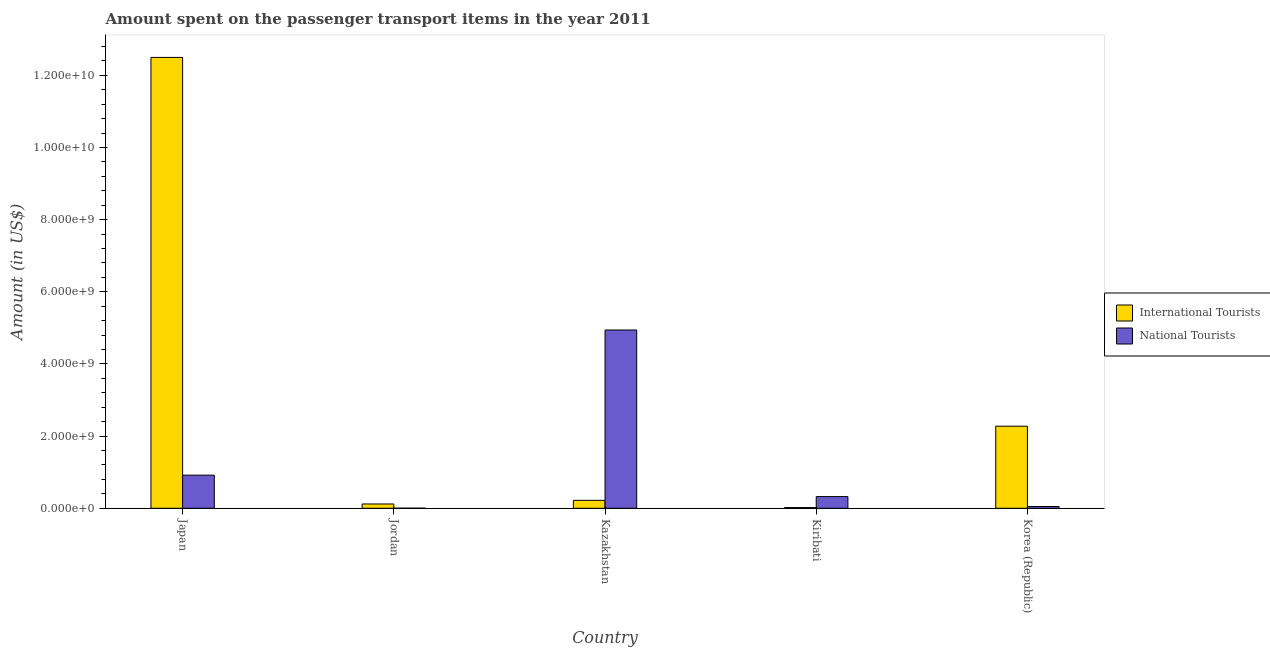How many groups of bars are there?
Ensure brevity in your answer.  5. Are the number of bars per tick equal to the number of legend labels?
Offer a terse response. Yes. What is the label of the 5th group of bars from the left?
Your answer should be very brief. Korea (Republic). In how many cases, is the number of bars for a given country not equal to the number of legend labels?
Make the answer very short. 0. What is the amount spent on transport items of national tourists in Kazakhstan?
Your answer should be compact. 4.94e+09. Across all countries, what is the maximum amount spent on transport items of international tourists?
Your answer should be compact. 1.25e+1. In which country was the amount spent on transport items of international tourists maximum?
Ensure brevity in your answer.  Japan. In which country was the amount spent on transport items of national tourists minimum?
Offer a very short reply. Jordan. What is the total amount spent on transport items of national tourists in the graph?
Ensure brevity in your answer.  6.24e+09. What is the difference between the amount spent on transport items of international tourists in Japan and that in Kiribati?
Your answer should be very brief. 1.25e+1. What is the difference between the amount spent on transport items of national tourists in Japan and the amount spent on transport items of international tourists in Korea (Republic)?
Provide a succinct answer. -1.36e+09. What is the average amount spent on transport items of international tourists per country?
Offer a terse response. 3.03e+09. What is the difference between the amount spent on transport items of international tourists and amount spent on transport items of national tourists in Korea (Republic)?
Keep it short and to the point. 2.23e+09. What is the ratio of the amount spent on transport items of international tourists in Kazakhstan to that in Korea (Republic)?
Your answer should be compact. 0.1. Is the difference between the amount spent on transport items of international tourists in Japan and Jordan greater than the difference between the amount spent on transport items of national tourists in Japan and Jordan?
Your answer should be compact. Yes. What is the difference between the highest and the second highest amount spent on transport items of national tourists?
Provide a short and direct response. 4.02e+09. What is the difference between the highest and the lowest amount spent on transport items of international tourists?
Ensure brevity in your answer.  1.25e+1. In how many countries, is the amount spent on transport items of international tourists greater than the average amount spent on transport items of international tourists taken over all countries?
Offer a terse response. 1. What does the 1st bar from the left in Jordan represents?
Your answer should be compact. International Tourists. What does the 2nd bar from the right in Jordan represents?
Offer a very short reply. International Tourists. What is the difference between two consecutive major ticks on the Y-axis?
Offer a very short reply. 2.00e+09. Are the values on the major ticks of Y-axis written in scientific E-notation?
Provide a short and direct response. Yes. Does the graph contain any zero values?
Ensure brevity in your answer.  No. Does the graph contain grids?
Your response must be concise. No. Where does the legend appear in the graph?
Offer a very short reply. Center right. How many legend labels are there?
Ensure brevity in your answer.  2. What is the title of the graph?
Provide a succinct answer. Amount spent on the passenger transport items in the year 2011. What is the Amount (in US$) in International Tourists in Japan?
Provide a succinct answer. 1.25e+1. What is the Amount (in US$) in National Tourists in Japan?
Offer a terse response. 9.18e+08. What is the Amount (in US$) of International Tourists in Jordan?
Make the answer very short. 1.19e+08. What is the Amount (in US$) in National Tourists in Jordan?
Make the answer very short. 2.00e+06. What is the Amount (in US$) of International Tourists in Kazakhstan?
Ensure brevity in your answer.  2.20e+08. What is the Amount (in US$) of National Tourists in Kazakhstan?
Provide a succinct answer. 4.94e+09. What is the Amount (in US$) of International Tourists in Kiribati?
Provide a short and direct response. 1.95e+07. What is the Amount (in US$) in National Tourists in Kiribati?
Offer a terse response. 3.24e+08. What is the Amount (in US$) of International Tourists in Korea (Republic)?
Make the answer very short. 2.28e+09. What is the Amount (in US$) of National Tourists in Korea (Republic)?
Provide a succinct answer. 4.90e+07. Across all countries, what is the maximum Amount (in US$) of International Tourists?
Provide a succinct answer. 1.25e+1. Across all countries, what is the maximum Amount (in US$) in National Tourists?
Your answer should be compact. 4.94e+09. Across all countries, what is the minimum Amount (in US$) in International Tourists?
Keep it short and to the point. 1.95e+07. What is the total Amount (in US$) in International Tourists in the graph?
Provide a short and direct response. 1.51e+1. What is the total Amount (in US$) in National Tourists in the graph?
Provide a succinct answer. 6.24e+09. What is the difference between the Amount (in US$) in International Tourists in Japan and that in Jordan?
Offer a terse response. 1.24e+1. What is the difference between the Amount (in US$) of National Tourists in Japan and that in Jordan?
Your answer should be very brief. 9.16e+08. What is the difference between the Amount (in US$) in International Tourists in Japan and that in Kazakhstan?
Keep it short and to the point. 1.23e+1. What is the difference between the Amount (in US$) of National Tourists in Japan and that in Kazakhstan?
Provide a succinct answer. -4.02e+09. What is the difference between the Amount (in US$) of International Tourists in Japan and that in Kiribati?
Your answer should be compact. 1.25e+1. What is the difference between the Amount (in US$) of National Tourists in Japan and that in Kiribati?
Keep it short and to the point. 5.94e+08. What is the difference between the Amount (in US$) in International Tourists in Japan and that in Korea (Republic)?
Your answer should be compact. 1.02e+1. What is the difference between the Amount (in US$) in National Tourists in Japan and that in Korea (Republic)?
Give a very brief answer. 8.69e+08. What is the difference between the Amount (in US$) of International Tourists in Jordan and that in Kazakhstan?
Your answer should be compact. -1.01e+08. What is the difference between the Amount (in US$) in National Tourists in Jordan and that in Kazakhstan?
Your answer should be very brief. -4.94e+09. What is the difference between the Amount (in US$) of International Tourists in Jordan and that in Kiribati?
Offer a terse response. 9.95e+07. What is the difference between the Amount (in US$) of National Tourists in Jordan and that in Kiribati?
Ensure brevity in your answer.  -3.22e+08. What is the difference between the Amount (in US$) of International Tourists in Jordan and that in Korea (Republic)?
Ensure brevity in your answer.  -2.16e+09. What is the difference between the Amount (in US$) of National Tourists in Jordan and that in Korea (Republic)?
Keep it short and to the point. -4.70e+07. What is the difference between the Amount (in US$) of International Tourists in Kazakhstan and that in Kiribati?
Your answer should be very brief. 2.00e+08. What is the difference between the Amount (in US$) in National Tourists in Kazakhstan and that in Kiribati?
Give a very brief answer. 4.62e+09. What is the difference between the Amount (in US$) in International Tourists in Kazakhstan and that in Korea (Republic)?
Your answer should be compact. -2.06e+09. What is the difference between the Amount (in US$) of National Tourists in Kazakhstan and that in Korea (Republic)?
Your response must be concise. 4.89e+09. What is the difference between the Amount (in US$) of International Tourists in Kiribati and that in Korea (Republic)?
Ensure brevity in your answer.  -2.26e+09. What is the difference between the Amount (in US$) of National Tourists in Kiribati and that in Korea (Republic)?
Offer a very short reply. 2.75e+08. What is the difference between the Amount (in US$) in International Tourists in Japan and the Amount (in US$) in National Tourists in Jordan?
Provide a short and direct response. 1.25e+1. What is the difference between the Amount (in US$) of International Tourists in Japan and the Amount (in US$) of National Tourists in Kazakhstan?
Your answer should be compact. 7.56e+09. What is the difference between the Amount (in US$) of International Tourists in Japan and the Amount (in US$) of National Tourists in Kiribati?
Your response must be concise. 1.22e+1. What is the difference between the Amount (in US$) in International Tourists in Japan and the Amount (in US$) in National Tourists in Korea (Republic)?
Provide a short and direct response. 1.24e+1. What is the difference between the Amount (in US$) of International Tourists in Jordan and the Amount (in US$) of National Tourists in Kazakhstan?
Your answer should be very brief. -4.82e+09. What is the difference between the Amount (in US$) of International Tourists in Jordan and the Amount (in US$) of National Tourists in Kiribati?
Your answer should be very brief. -2.05e+08. What is the difference between the Amount (in US$) of International Tourists in Jordan and the Amount (in US$) of National Tourists in Korea (Republic)?
Give a very brief answer. 7.00e+07. What is the difference between the Amount (in US$) in International Tourists in Kazakhstan and the Amount (in US$) in National Tourists in Kiribati?
Keep it short and to the point. -1.04e+08. What is the difference between the Amount (in US$) of International Tourists in Kazakhstan and the Amount (in US$) of National Tourists in Korea (Republic)?
Make the answer very short. 1.71e+08. What is the difference between the Amount (in US$) in International Tourists in Kiribati and the Amount (in US$) in National Tourists in Korea (Republic)?
Give a very brief answer. -2.95e+07. What is the average Amount (in US$) in International Tourists per country?
Keep it short and to the point. 3.03e+09. What is the average Amount (in US$) in National Tourists per country?
Your answer should be very brief. 1.25e+09. What is the difference between the Amount (in US$) in International Tourists and Amount (in US$) in National Tourists in Japan?
Make the answer very short. 1.16e+1. What is the difference between the Amount (in US$) of International Tourists and Amount (in US$) of National Tourists in Jordan?
Ensure brevity in your answer.  1.17e+08. What is the difference between the Amount (in US$) of International Tourists and Amount (in US$) of National Tourists in Kazakhstan?
Your answer should be very brief. -4.72e+09. What is the difference between the Amount (in US$) in International Tourists and Amount (in US$) in National Tourists in Kiribati?
Make the answer very short. -3.04e+08. What is the difference between the Amount (in US$) of International Tourists and Amount (in US$) of National Tourists in Korea (Republic)?
Your answer should be compact. 2.23e+09. What is the ratio of the Amount (in US$) in International Tourists in Japan to that in Jordan?
Offer a very short reply. 105.03. What is the ratio of the Amount (in US$) of National Tourists in Japan to that in Jordan?
Offer a very short reply. 459. What is the ratio of the Amount (in US$) in International Tourists in Japan to that in Kazakhstan?
Provide a short and direct response. 56.81. What is the ratio of the Amount (in US$) in National Tourists in Japan to that in Kazakhstan?
Your answer should be compact. 0.19. What is the ratio of the Amount (in US$) of International Tourists in Japan to that in Kiribati?
Offer a very short reply. 640.92. What is the ratio of the Amount (in US$) in National Tourists in Japan to that in Kiribati?
Give a very brief answer. 2.83. What is the ratio of the Amount (in US$) of International Tourists in Japan to that in Korea (Republic)?
Your answer should be very brief. 5.49. What is the ratio of the Amount (in US$) in National Tourists in Japan to that in Korea (Republic)?
Offer a very short reply. 18.73. What is the ratio of the Amount (in US$) in International Tourists in Jordan to that in Kazakhstan?
Make the answer very short. 0.54. What is the ratio of the Amount (in US$) in National Tourists in Jordan to that in Kazakhstan?
Make the answer very short. 0. What is the ratio of the Amount (in US$) in International Tourists in Jordan to that in Kiribati?
Make the answer very short. 6.1. What is the ratio of the Amount (in US$) of National Tourists in Jordan to that in Kiribati?
Offer a very short reply. 0.01. What is the ratio of the Amount (in US$) in International Tourists in Jordan to that in Korea (Republic)?
Keep it short and to the point. 0.05. What is the ratio of the Amount (in US$) in National Tourists in Jordan to that in Korea (Republic)?
Your answer should be very brief. 0.04. What is the ratio of the Amount (in US$) in International Tourists in Kazakhstan to that in Kiribati?
Offer a terse response. 11.28. What is the ratio of the Amount (in US$) of National Tourists in Kazakhstan to that in Kiribati?
Make the answer very short. 15.25. What is the ratio of the Amount (in US$) in International Tourists in Kazakhstan to that in Korea (Republic)?
Offer a terse response. 0.1. What is the ratio of the Amount (in US$) in National Tourists in Kazakhstan to that in Korea (Republic)?
Your response must be concise. 100.86. What is the ratio of the Amount (in US$) of International Tourists in Kiribati to that in Korea (Republic)?
Ensure brevity in your answer.  0.01. What is the ratio of the Amount (in US$) of National Tourists in Kiribati to that in Korea (Republic)?
Ensure brevity in your answer.  6.61. What is the difference between the highest and the second highest Amount (in US$) of International Tourists?
Offer a very short reply. 1.02e+1. What is the difference between the highest and the second highest Amount (in US$) in National Tourists?
Keep it short and to the point. 4.02e+09. What is the difference between the highest and the lowest Amount (in US$) in International Tourists?
Your answer should be compact. 1.25e+1. What is the difference between the highest and the lowest Amount (in US$) in National Tourists?
Make the answer very short. 4.94e+09. 